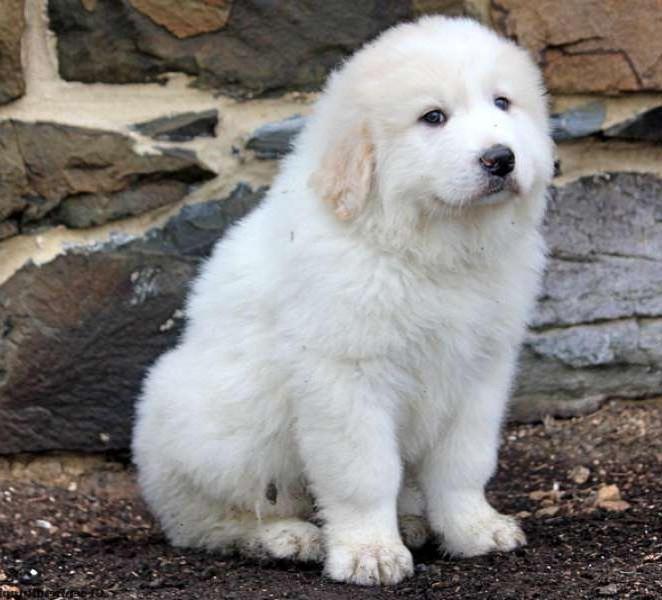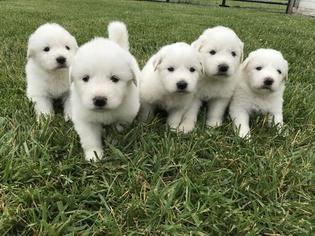The first image is the image on the left, the second image is the image on the right. Examine the images to the left and right. Is the description "A white furry dog is in front of a group of sheep." accurate? Answer yes or no. No. The first image is the image on the left, the second image is the image on the right. Analyze the images presented: Is the assertion "There are more animals in the image on the right." valid? Answer yes or no. Yes. 